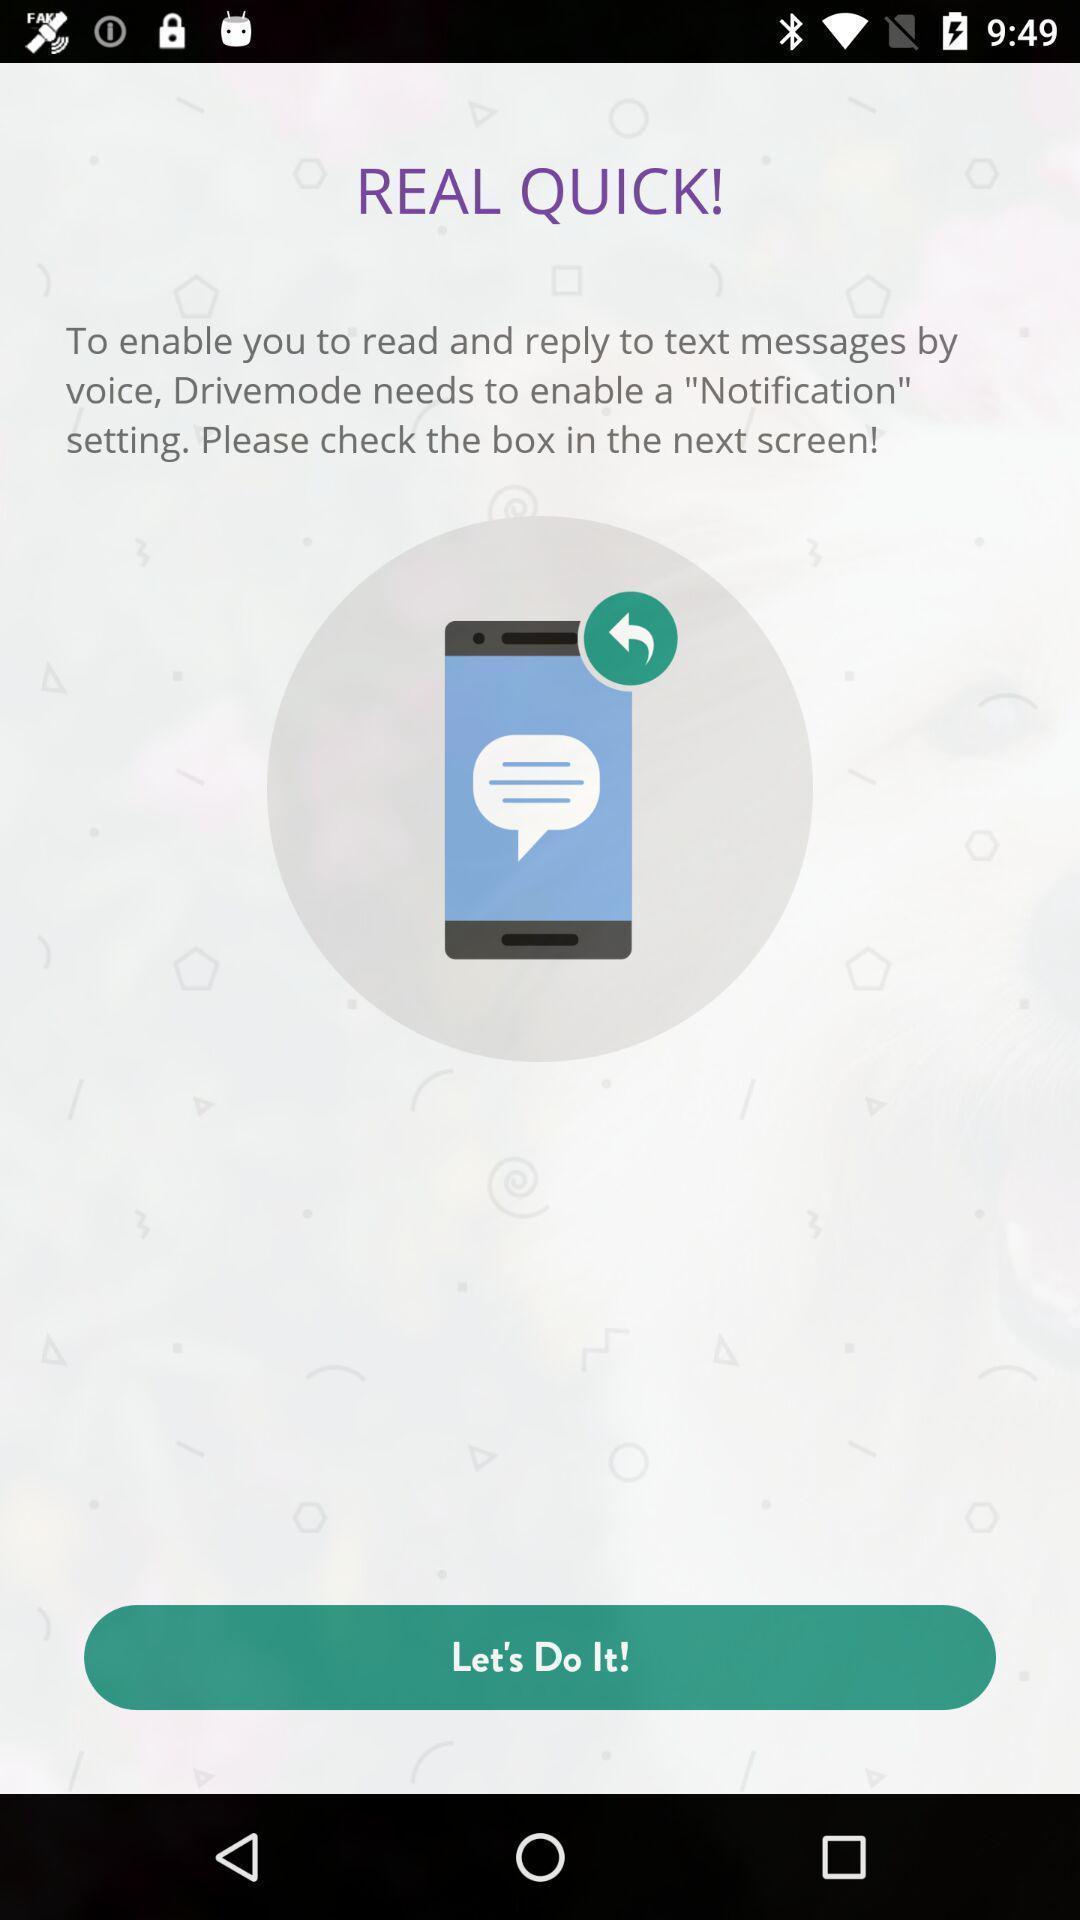Tell me about the visual elements in this screen capture. Screen shows information. 